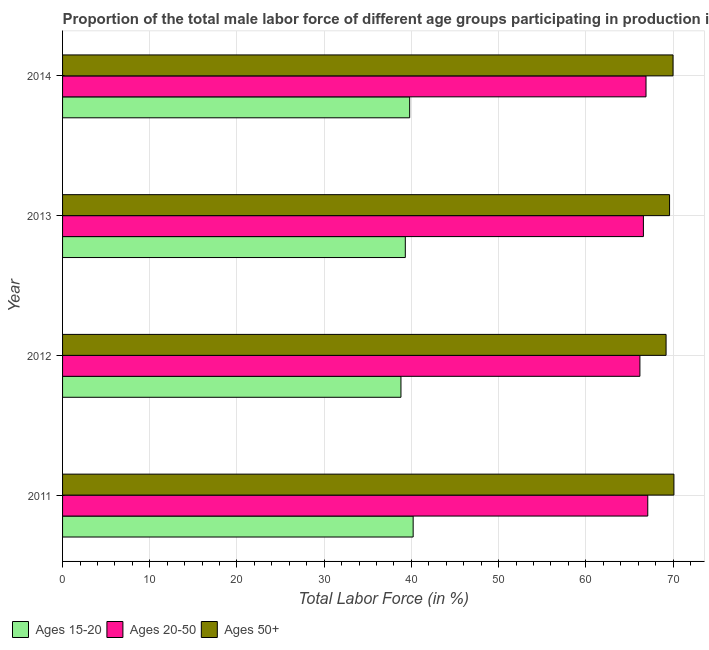How many groups of bars are there?
Offer a terse response. 4. Are the number of bars per tick equal to the number of legend labels?
Make the answer very short. Yes. Are the number of bars on each tick of the Y-axis equal?
Ensure brevity in your answer.  Yes. How many bars are there on the 4th tick from the top?
Your answer should be compact. 3. In how many cases, is the number of bars for a given year not equal to the number of legend labels?
Ensure brevity in your answer.  0. What is the percentage of male labor force within the age group 20-50 in 2012?
Offer a terse response. 66.2. Across all years, what is the maximum percentage of male labor force within the age group 20-50?
Offer a very short reply. 67.1. Across all years, what is the minimum percentage of male labor force within the age group 20-50?
Provide a succinct answer. 66.2. What is the total percentage of male labor force above age 50 in the graph?
Your answer should be compact. 278.9. What is the difference between the percentage of male labor force above age 50 in 2012 and the percentage of male labor force within the age group 15-20 in 2014?
Provide a succinct answer. 29.4. What is the average percentage of male labor force within the age group 15-20 per year?
Keep it short and to the point. 39.52. In the year 2013, what is the difference between the percentage of male labor force within the age group 20-50 and percentage of male labor force within the age group 15-20?
Offer a very short reply. 27.3. In how many years, is the percentage of male labor force within the age group 15-20 greater than the average percentage of male labor force within the age group 15-20 taken over all years?
Ensure brevity in your answer.  2. Is the sum of the percentage of male labor force within the age group 15-20 in 2011 and 2013 greater than the maximum percentage of male labor force above age 50 across all years?
Provide a succinct answer. Yes. What does the 3rd bar from the top in 2012 represents?
Offer a terse response. Ages 15-20. What does the 1st bar from the bottom in 2013 represents?
Provide a succinct answer. Ages 15-20. Is it the case that in every year, the sum of the percentage of male labor force within the age group 15-20 and percentage of male labor force within the age group 20-50 is greater than the percentage of male labor force above age 50?
Your answer should be very brief. Yes. Are all the bars in the graph horizontal?
Give a very brief answer. Yes. What is the difference between two consecutive major ticks on the X-axis?
Offer a terse response. 10. Are the values on the major ticks of X-axis written in scientific E-notation?
Make the answer very short. No. Where does the legend appear in the graph?
Provide a succinct answer. Bottom left. How many legend labels are there?
Provide a succinct answer. 3. How are the legend labels stacked?
Make the answer very short. Horizontal. What is the title of the graph?
Make the answer very short. Proportion of the total male labor force of different age groups participating in production in Jordan. Does "Ages 0-14" appear as one of the legend labels in the graph?
Offer a terse response. No. What is the label or title of the Y-axis?
Offer a terse response. Year. What is the Total Labor Force (in %) in Ages 15-20 in 2011?
Offer a terse response. 40.2. What is the Total Labor Force (in %) in Ages 20-50 in 2011?
Offer a very short reply. 67.1. What is the Total Labor Force (in %) of Ages 50+ in 2011?
Keep it short and to the point. 70.1. What is the Total Labor Force (in %) of Ages 15-20 in 2012?
Provide a short and direct response. 38.8. What is the Total Labor Force (in %) of Ages 20-50 in 2012?
Provide a short and direct response. 66.2. What is the Total Labor Force (in %) of Ages 50+ in 2012?
Ensure brevity in your answer.  69.2. What is the Total Labor Force (in %) of Ages 15-20 in 2013?
Provide a succinct answer. 39.3. What is the Total Labor Force (in %) of Ages 20-50 in 2013?
Make the answer very short. 66.6. What is the Total Labor Force (in %) of Ages 50+ in 2013?
Your answer should be compact. 69.6. What is the Total Labor Force (in %) of Ages 15-20 in 2014?
Your answer should be compact. 39.8. What is the Total Labor Force (in %) of Ages 20-50 in 2014?
Provide a succinct answer. 66.9. Across all years, what is the maximum Total Labor Force (in %) of Ages 15-20?
Provide a succinct answer. 40.2. Across all years, what is the maximum Total Labor Force (in %) in Ages 20-50?
Offer a very short reply. 67.1. Across all years, what is the maximum Total Labor Force (in %) of Ages 50+?
Give a very brief answer. 70.1. Across all years, what is the minimum Total Labor Force (in %) of Ages 15-20?
Offer a terse response. 38.8. Across all years, what is the minimum Total Labor Force (in %) of Ages 20-50?
Your response must be concise. 66.2. Across all years, what is the minimum Total Labor Force (in %) of Ages 50+?
Provide a short and direct response. 69.2. What is the total Total Labor Force (in %) of Ages 15-20 in the graph?
Offer a very short reply. 158.1. What is the total Total Labor Force (in %) in Ages 20-50 in the graph?
Give a very brief answer. 266.8. What is the total Total Labor Force (in %) in Ages 50+ in the graph?
Give a very brief answer. 278.9. What is the difference between the Total Labor Force (in %) in Ages 20-50 in 2011 and that in 2012?
Your response must be concise. 0.9. What is the difference between the Total Labor Force (in %) in Ages 50+ in 2011 and that in 2012?
Offer a very short reply. 0.9. What is the difference between the Total Labor Force (in %) of Ages 20-50 in 2011 and that in 2013?
Offer a very short reply. 0.5. What is the difference between the Total Labor Force (in %) in Ages 50+ in 2011 and that in 2013?
Keep it short and to the point. 0.5. What is the difference between the Total Labor Force (in %) in Ages 15-20 in 2011 and that in 2014?
Ensure brevity in your answer.  0.4. What is the difference between the Total Labor Force (in %) of Ages 20-50 in 2011 and that in 2014?
Offer a very short reply. 0.2. What is the difference between the Total Labor Force (in %) in Ages 15-20 in 2012 and that in 2013?
Offer a very short reply. -0.5. What is the difference between the Total Labor Force (in %) in Ages 50+ in 2012 and that in 2013?
Your answer should be compact. -0.4. What is the difference between the Total Labor Force (in %) of Ages 15-20 in 2012 and that in 2014?
Provide a succinct answer. -1. What is the difference between the Total Labor Force (in %) in Ages 50+ in 2012 and that in 2014?
Your answer should be very brief. -0.8. What is the difference between the Total Labor Force (in %) of Ages 20-50 in 2013 and that in 2014?
Provide a short and direct response. -0.3. What is the difference between the Total Labor Force (in %) in Ages 15-20 in 2011 and the Total Labor Force (in %) in Ages 20-50 in 2013?
Your response must be concise. -26.4. What is the difference between the Total Labor Force (in %) in Ages 15-20 in 2011 and the Total Labor Force (in %) in Ages 50+ in 2013?
Keep it short and to the point. -29.4. What is the difference between the Total Labor Force (in %) in Ages 20-50 in 2011 and the Total Labor Force (in %) in Ages 50+ in 2013?
Your answer should be very brief. -2.5. What is the difference between the Total Labor Force (in %) of Ages 15-20 in 2011 and the Total Labor Force (in %) of Ages 20-50 in 2014?
Provide a short and direct response. -26.7. What is the difference between the Total Labor Force (in %) in Ages 15-20 in 2011 and the Total Labor Force (in %) in Ages 50+ in 2014?
Your answer should be very brief. -29.8. What is the difference between the Total Labor Force (in %) of Ages 15-20 in 2012 and the Total Labor Force (in %) of Ages 20-50 in 2013?
Provide a succinct answer. -27.8. What is the difference between the Total Labor Force (in %) in Ages 15-20 in 2012 and the Total Labor Force (in %) in Ages 50+ in 2013?
Ensure brevity in your answer.  -30.8. What is the difference between the Total Labor Force (in %) in Ages 15-20 in 2012 and the Total Labor Force (in %) in Ages 20-50 in 2014?
Offer a terse response. -28.1. What is the difference between the Total Labor Force (in %) in Ages 15-20 in 2012 and the Total Labor Force (in %) in Ages 50+ in 2014?
Offer a very short reply. -31.2. What is the difference between the Total Labor Force (in %) of Ages 20-50 in 2012 and the Total Labor Force (in %) of Ages 50+ in 2014?
Your answer should be compact. -3.8. What is the difference between the Total Labor Force (in %) in Ages 15-20 in 2013 and the Total Labor Force (in %) in Ages 20-50 in 2014?
Give a very brief answer. -27.6. What is the difference between the Total Labor Force (in %) of Ages 15-20 in 2013 and the Total Labor Force (in %) of Ages 50+ in 2014?
Offer a terse response. -30.7. What is the average Total Labor Force (in %) in Ages 15-20 per year?
Provide a succinct answer. 39.52. What is the average Total Labor Force (in %) in Ages 20-50 per year?
Make the answer very short. 66.7. What is the average Total Labor Force (in %) of Ages 50+ per year?
Your answer should be compact. 69.72. In the year 2011, what is the difference between the Total Labor Force (in %) of Ages 15-20 and Total Labor Force (in %) of Ages 20-50?
Your response must be concise. -26.9. In the year 2011, what is the difference between the Total Labor Force (in %) in Ages 15-20 and Total Labor Force (in %) in Ages 50+?
Offer a very short reply. -29.9. In the year 2012, what is the difference between the Total Labor Force (in %) in Ages 15-20 and Total Labor Force (in %) in Ages 20-50?
Give a very brief answer. -27.4. In the year 2012, what is the difference between the Total Labor Force (in %) in Ages 15-20 and Total Labor Force (in %) in Ages 50+?
Your answer should be very brief. -30.4. In the year 2012, what is the difference between the Total Labor Force (in %) in Ages 20-50 and Total Labor Force (in %) in Ages 50+?
Give a very brief answer. -3. In the year 2013, what is the difference between the Total Labor Force (in %) in Ages 15-20 and Total Labor Force (in %) in Ages 20-50?
Make the answer very short. -27.3. In the year 2013, what is the difference between the Total Labor Force (in %) of Ages 15-20 and Total Labor Force (in %) of Ages 50+?
Ensure brevity in your answer.  -30.3. In the year 2014, what is the difference between the Total Labor Force (in %) of Ages 15-20 and Total Labor Force (in %) of Ages 20-50?
Keep it short and to the point. -27.1. In the year 2014, what is the difference between the Total Labor Force (in %) in Ages 15-20 and Total Labor Force (in %) in Ages 50+?
Offer a terse response. -30.2. What is the ratio of the Total Labor Force (in %) in Ages 15-20 in 2011 to that in 2012?
Give a very brief answer. 1.04. What is the ratio of the Total Labor Force (in %) of Ages 20-50 in 2011 to that in 2012?
Your answer should be very brief. 1.01. What is the ratio of the Total Labor Force (in %) of Ages 15-20 in 2011 to that in 2013?
Keep it short and to the point. 1.02. What is the ratio of the Total Labor Force (in %) of Ages 20-50 in 2011 to that in 2013?
Give a very brief answer. 1.01. What is the ratio of the Total Labor Force (in %) in Ages 50+ in 2011 to that in 2013?
Offer a terse response. 1.01. What is the ratio of the Total Labor Force (in %) in Ages 20-50 in 2011 to that in 2014?
Offer a very short reply. 1. What is the ratio of the Total Labor Force (in %) of Ages 50+ in 2011 to that in 2014?
Provide a succinct answer. 1. What is the ratio of the Total Labor Force (in %) in Ages 15-20 in 2012 to that in 2013?
Your answer should be very brief. 0.99. What is the ratio of the Total Labor Force (in %) of Ages 20-50 in 2012 to that in 2013?
Your answer should be compact. 0.99. What is the ratio of the Total Labor Force (in %) of Ages 15-20 in 2012 to that in 2014?
Make the answer very short. 0.97. What is the ratio of the Total Labor Force (in %) in Ages 20-50 in 2012 to that in 2014?
Offer a terse response. 0.99. What is the ratio of the Total Labor Force (in %) of Ages 50+ in 2012 to that in 2014?
Keep it short and to the point. 0.99. What is the ratio of the Total Labor Force (in %) in Ages 15-20 in 2013 to that in 2014?
Ensure brevity in your answer.  0.99. What is the ratio of the Total Labor Force (in %) of Ages 50+ in 2013 to that in 2014?
Ensure brevity in your answer.  0.99. What is the difference between the highest and the second highest Total Labor Force (in %) in Ages 15-20?
Your answer should be compact. 0.4. What is the difference between the highest and the second highest Total Labor Force (in %) of Ages 20-50?
Ensure brevity in your answer.  0.2. What is the difference between the highest and the lowest Total Labor Force (in %) in Ages 15-20?
Make the answer very short. 1.4. What is the difference between the highest and the lowest Total Labor Force (in %) in Ages 20-50?
Offer a very short reply. 0.9. 